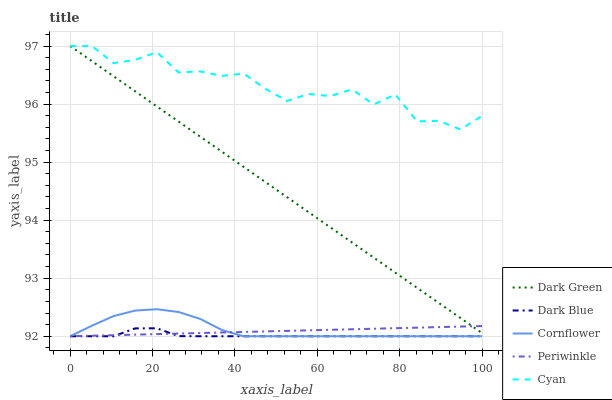Does Dark Blue have the minimum area under the curve?
Answer yes or no. Yes. Does Cyan have the maximum area under the curve?
Answer yes or no. Yes. Does Periwinkle have the minimum area under the curve?
Answer yes or no. No. Does Periwinkle have the maximum area under the curve?
Answer yes or no. No. Is Periwinkle the smoothest?
Answer yes or no. Yes. Is Cyan the roughest?
Answer yes or no. Yes. Is Cyan the smoothest?
Answer yes or no. No. Is Periwinkle the roughest?
Answer yes or no. No. Does Dark Blue have the lowest value?
Answer yes or no. Yes. Does Cyan have the lowest value?
Answer yes or no. No. Does Dark Green have the highest value?
Answer yes or no. Yes. Does Periwinkle have the highest value?
Answer yes or no. No. Is Dark Blue less than Cyan?
Answer yes or no. Yes. Is Dark Green greater than Dark Blue?
Answer yes or no. Yes. Does Periwinkle intersect Cornflower?
Answer yes or no. Yes. Is Periwinkle less than Cornflower?
Answer yes or no. No. Is Periwinkle greater than Cornflower?
Answer yes or no. No. Does Dark Blue intersect Cyan?
Answer yes or no. No. 